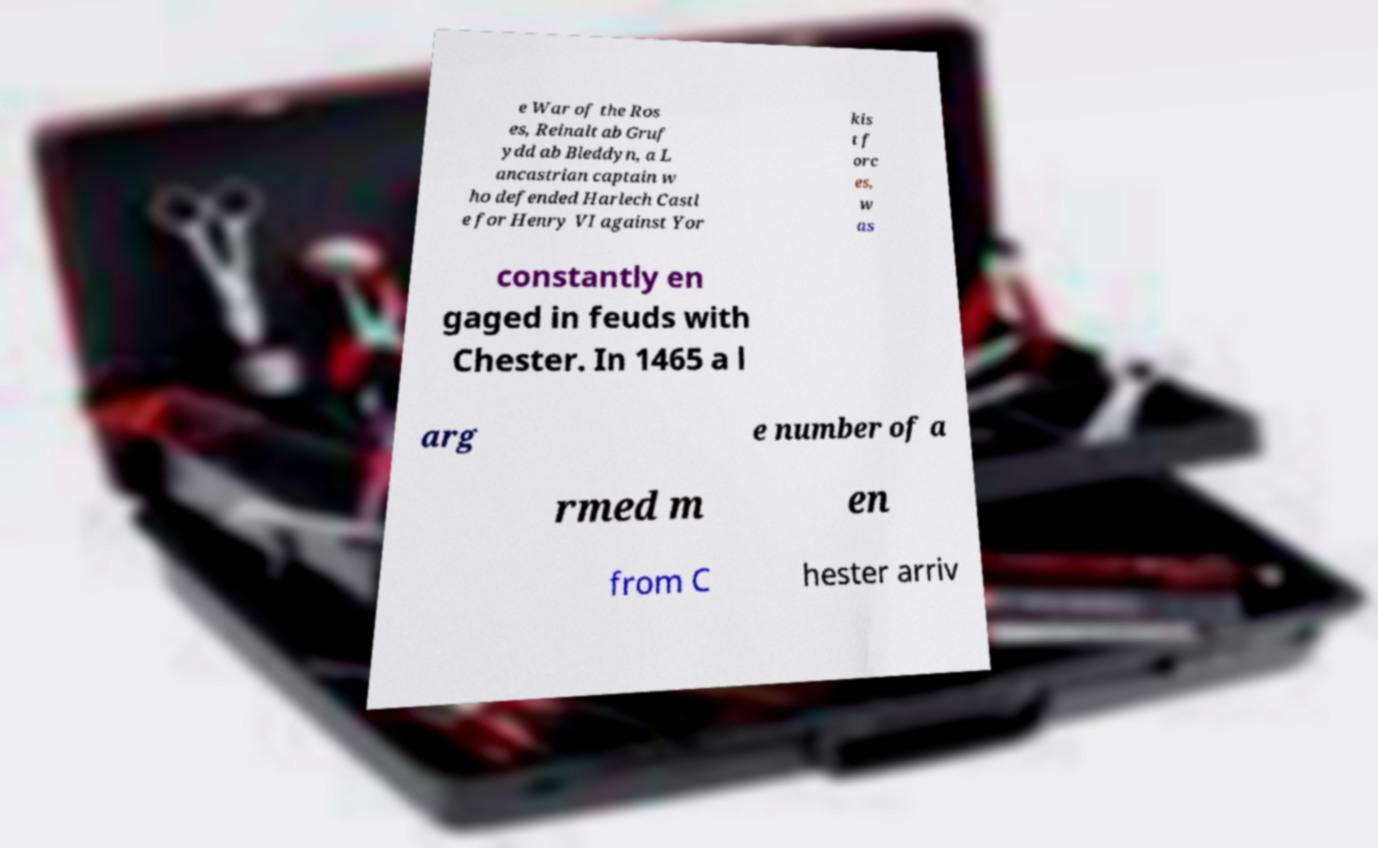Could you extract and type out the text from this image? e War of the Ros es, Reinalt ab Gruf ydd ab Bleddyn, a L ancastrian captain w ho defended Harlech Castl e for Henry VI against Yor kis t f orc es, w as constantly en gaged in feuds with Chester. In 1465 a l arg e number of a rmed m en from C hester arriv 